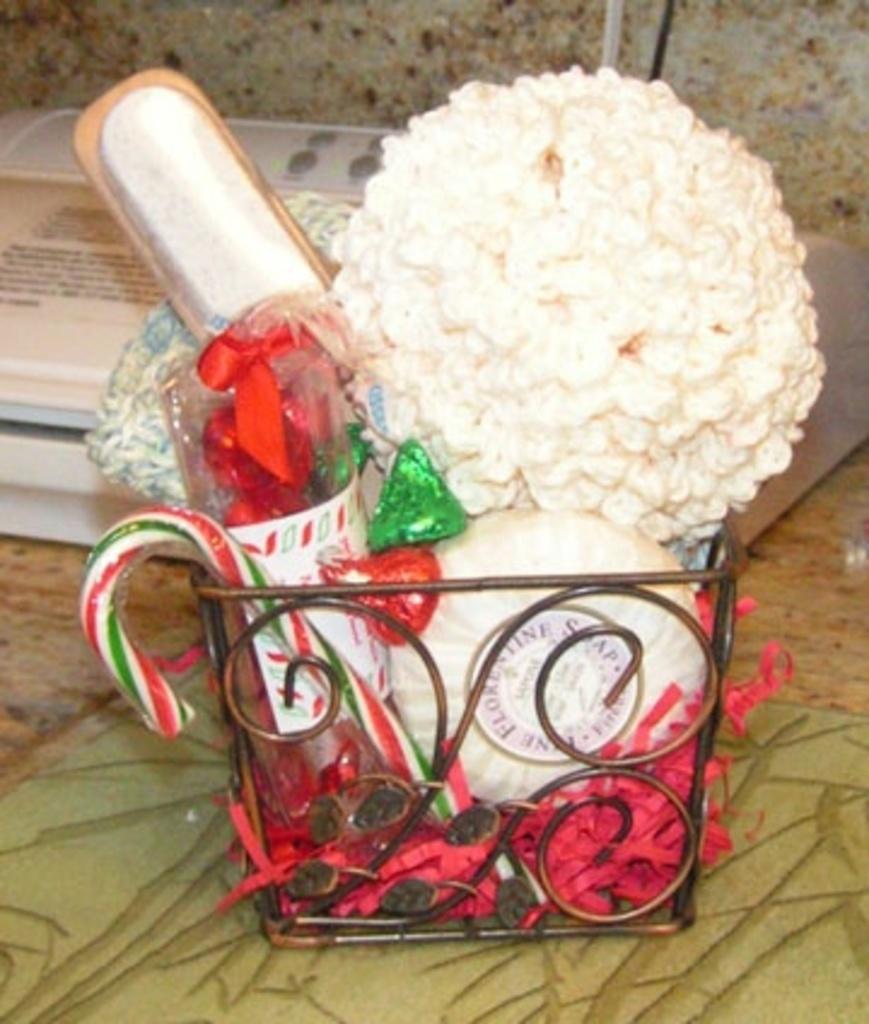Can you describe this image briefly? In this picture we can see a basket, on which we can see few objects are placed, behind we can see one box. 